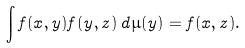Convert formula to latex. <formula><loc_0><loc_0><loc_500><loc_500>\int f ( x , y ) f ( y , z ) \, d \mu ( y ) = f ( x , z ) .</formula> 